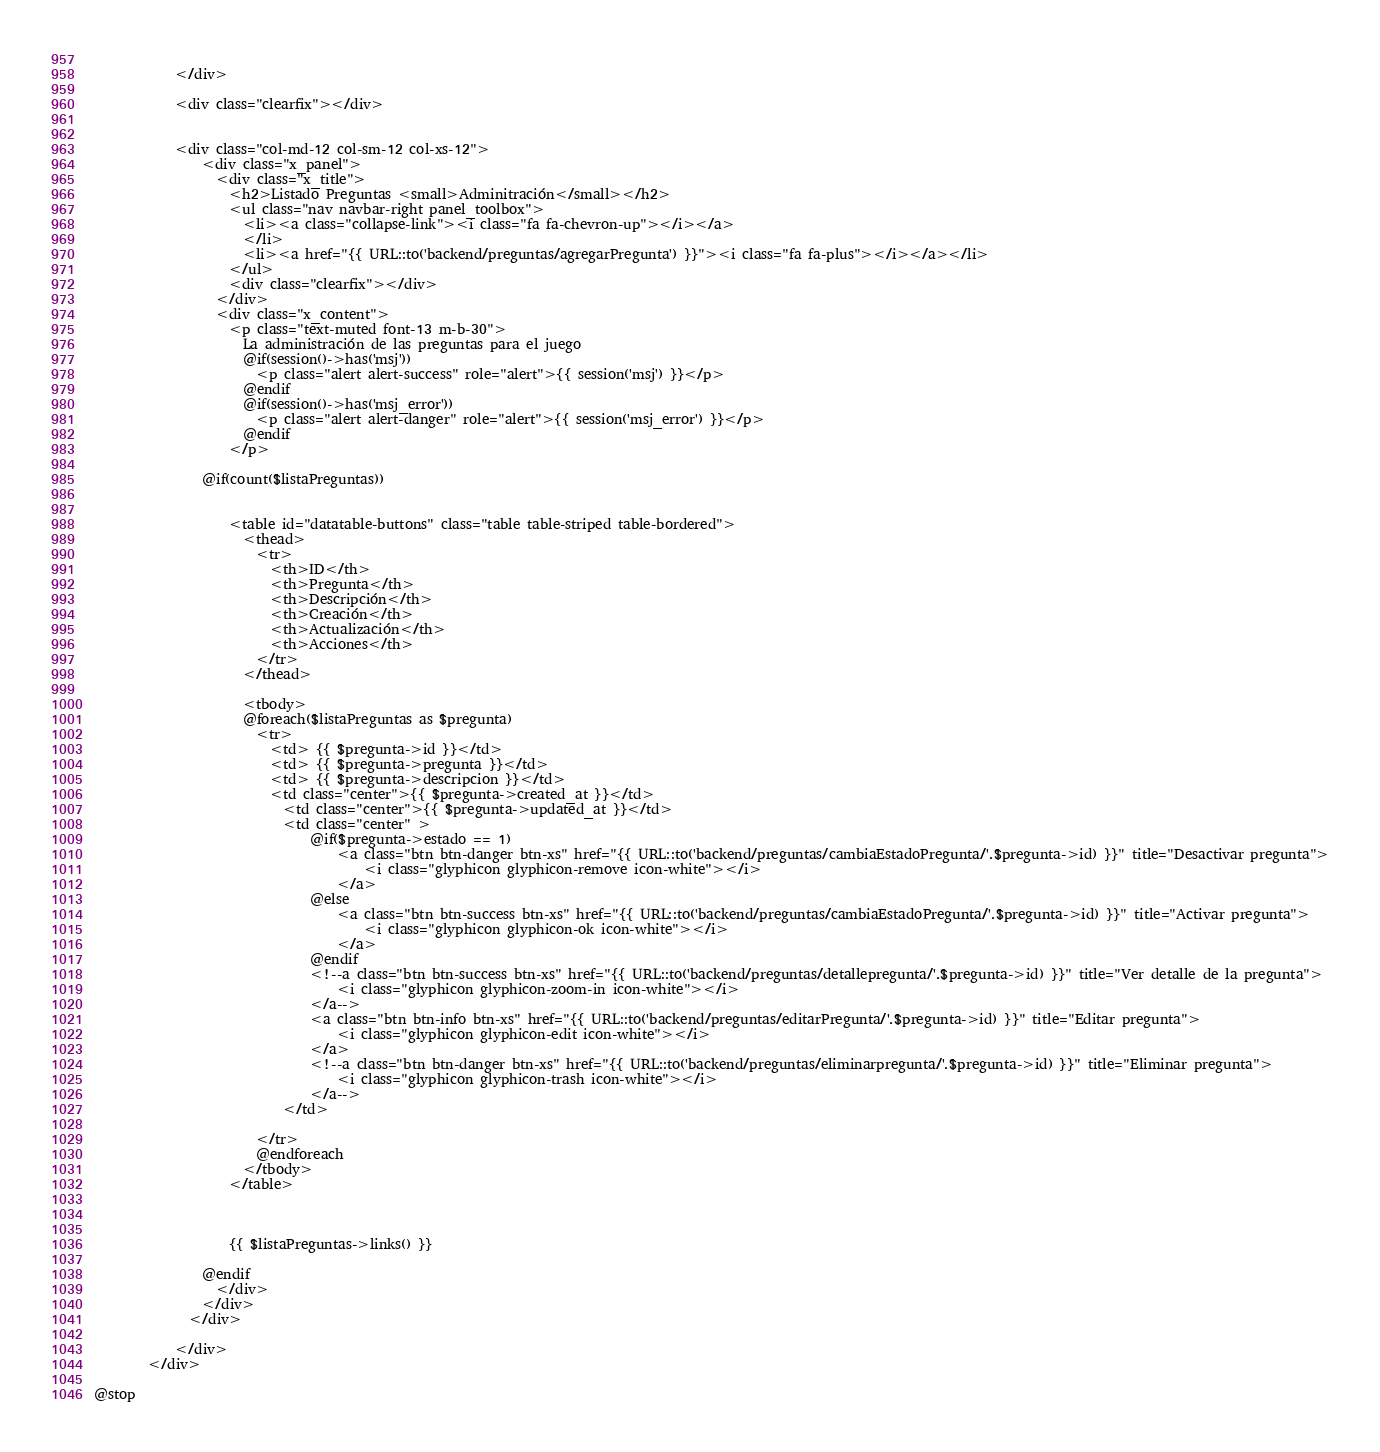<code> <loc_0><loc_0><loc_500><loc_500><_PHP_>              
            </div>

            <div class="clearfix"></div>


            <div class="col-md-12 col-sm-12 col-xs-12">
                <div class="x_panel">
                  <div class="x_title">
                    <h2>Listado Preguntas <small>Adminitración</small></h2>
                    <ul class="nav navbar-right panel_toolbox">
                      <li><a class="collapse-link"><i class="fa fa-chevron-up"></i></a>
                      </li>
                      <li><a href="{{ URL::to('backend/preguntas/agregarPregunta') }}"><i class="fa fa-plus"></i></a></li>
                    </ul>
                    <div class="clearfix"></div>
                  </div>
                  <div class="x_content">
                    <p class="text-muted font-13 m-b-30">
                      La administración de las preguntas para el juego
                      @if(session()->has('msj'))
                        <p class="alert alert-success" role="alert">{{ session('msj') }}</p>
                      @endif
                      @if(session()->has('msj_error'))
                        <p class="alert alert-danger" role="alert">{{ session('msj_error') }}</p>
                      @endif
                    </p>

                @if(count($listaPreguntas))

           
                    <table id="datatable-buttons" class="table table-striped table-bordered">
                      <thead>
                        <tr>
                          <th>ID</th>
                          <th>Pregunta</th>
                          <th>Descripción</th>
                          <th>Creación</th>
                          <th>Actualización</th>
                          <th>Acciones</th>
                        </tr>
                      </thead>

                      <tbody>
                      @foreach($listaPreguntas as $pregunta)
                        <tr>
                          <td> {{ $pregunta->id }}</td>
                          <td> {{ $pregunta->pregunta }}</td>
                          <td> {{ $pregunta->descripcion }}</td>
                          <td class="center">{{ $pregunta->created_at }}</td>
                            <td class="center">{{ $pregunta->updated_at }}</td>
                            <td class="center" >
                                @if($pregunta->estado == 1)
                                    <a class="btn btn-danger btn-xs" href="{{ URL::to('backend/preguntas/cambiaEstadoPregunta/'.$pregunta->id) }}" title="Desactivar pregunta">
                                        <i class="glyphicon glyphicon-remove icon-white"></i>
                                    </a>
                                @else
                                    <a class="btn btn-success btn-xs" href="{{ URL::to('backend/preguntas/cambiaEstadoPregunta/'.$pregunta->id) }}" title="Activar pregunta">
                                        <i class="glyphicon glyphicon-ok icon-white"></i>
                                    </a>
                                @endif
                                <!--a class="btn btn-success btn-xs" href="{{ URL::to('backend/preguntas/detallepregunta/'.$pregunta->id) }}" title="Ver detalle de la pregunta">
                                    <i class="glyphicon glyphicon-zoom-in icon-white"></i>
                                </a-->
                                <a class="btn btn-info btn-xs" href="{{ URL::to('backend/preguntas/editarPregunta/'.$pregunta->id) }}" title="Editar pregunta">
                                    <i class="glyphicon glyphicon-edit icon-white"></i>
                                </a>
                                <!--a class="btn btn-danger btn-xs" href="{{ URL::to('backend/preguntas/eliminarpregunta/'.$pregunta->id) }}" title="Eliminar pregunta">
                                    <i class="glyphicon glyphicon-trash icon-white"></i>
                                </a-->
                            </td>

                        </tr>
                        @endforeach
                      </tbody>
                    </table>

                    

                    {{ $listaPreguntas->links() }}

                @endif
                  </div>
                </div>
              </div>

            </div>
        </div>

@stop</code> 